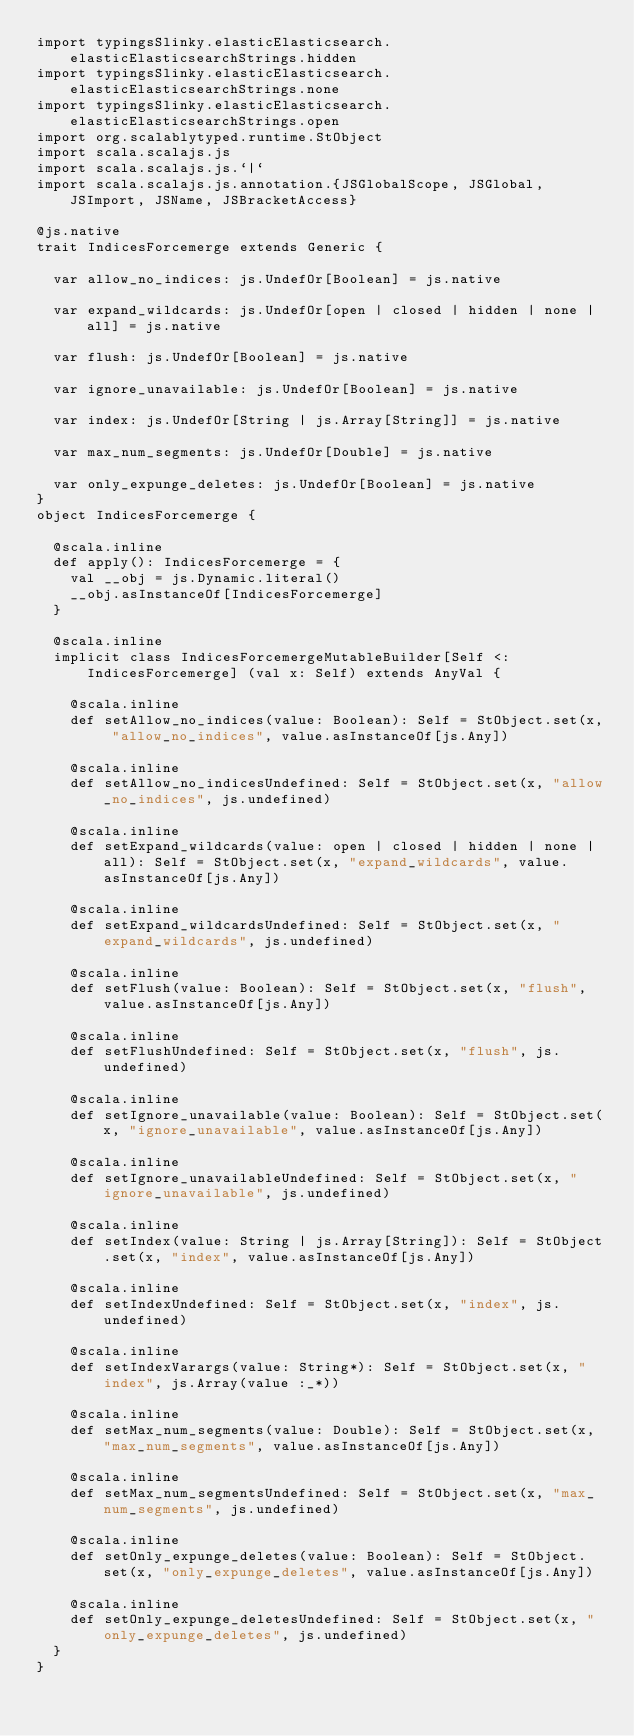Convert code to text. <code><loc_0><loc_0><loc_500><loc_500><_Scala_>import typingsSlinky.elasticElasticsearch.elasticElasticsearchStrings.hidden
import typingsSlinky.elasticElasticsearch.elasticElasticsearchStrings.none
import typingsSlinky.elasticElasticsearch.elasticElasticsearchStrings.open
import org.scalablytyped.runtime.StObject
import scala.scalajs.js
import scala.scalajs.js.`|`
import scala.scalajs.js.annotation.{JSGlobalScope, JSGlobal, JSImport, JSName, JSBracketAccess}

@js.native
trait IndicesForcemerge extends Generic {
  
  var allow_no_indices: js.UndefOr[Boolean] = js.native
  
  var expand_wildcards: js.UndefOr[open | closed | hidden | none | all] = js.native
  
  var flush: js.UndefOr[Boolean] = js.native
  
  var ignore_unavailable: js.UndefOr[Boolean] = js.native
  
  var index: js.UndefOr[String | js.Array[String]] = js.native
  
  var max_num_segments: js.UndefOr[Double] = js.native
  
  var only_expunge_deletes: js.UndefOr[Boolean] = js.native
}
object IndicesForcemerge {
  
  @scala.inline
  def apply(): IndicesForcemerge = {
    val __obj = js.Dynamic.literal()
    __obj.asInstanceOf[IndicesForcemerge]
  }
  
  @scala.inline
  implicit class IndicesForcemergeMutableBuilder[Self <: IndicesForcemerge] (val x: Self) extends AnyVal {
    
    @scala.inline
    def setAllow_no_indices(value: Boolean): Self = StObject.set(x, "allow_no_indices", value.asInstanceOf[js.Any])
    
    @scala.inline
    def setAllow_no_indicesUndefined: Self = StObject.set(x, "allow_no_indices", js.undefined)
    
    @scala.inline
    def setExpand_wildcards(value: open | closed | hidden | none | all): Self = StObject.set(x, "expand_wildcards", value.asInstanceOf[js.Any])
    
    @scala.inline
    def setExpand_wildcardsUndefined: Self = StObject.set(x, "expand_wildcards", js.undefined)
    
    @scala.inline
    def setFlush(value: Boolean): Self = StObject.set(x, "flush", value.asInstanceOf[js.Any])
    
    @scala.inline
    def setFlushUndefined: Self = StObject.set(x, "flush", js.undefined)
    
    @scala.inline
    def setIgnore_unavailable(value: Boolean): Self = StObject.set(x, "ignore_unavailable", value.asInstanceOf[js.Any])
    
    @scala.inline
    def setIgnore_unavailableUndefined: Self = StObject.set(x, "ignore_unavailable", js.undefined)
    
    @scala.inline
    def setIndex(value: String | js.Array[String]): Self = StObject.set(x, "index", value.asInstanceOf[js.Any])
    
    @scala.inline
    def setIndexUndefined: Self = StObject.set(x, "index", js.undefined)
    
    @scala.inline
    def setIndexVarargs(value: String*): Self = StObject.set(x, "index", js.Array(value :_*))
    
    @scala.inline
    def setMax_num_segments(value: Double): Self = StObject.set(x, "max_num_segments", value.asInstanceOf[js.Any])
    
    @scala.inline
    def setMax_num_segmentsUndefined: Self = StObject.set(x, "max_num_segments", js.undefined)
    
    @scala.inline
    def setOnly_expunge_deletes(value: Boolean): Self = StObject.set(x, "only_expunge_deletes", value.asInstanceOf[js.Any])
    
    @scala.inline
    def setOnly_expunge_deletesUndefined: Self = StObject.set(x, "only_expunge_deletes", js.undefined)
  }
}
</code> 